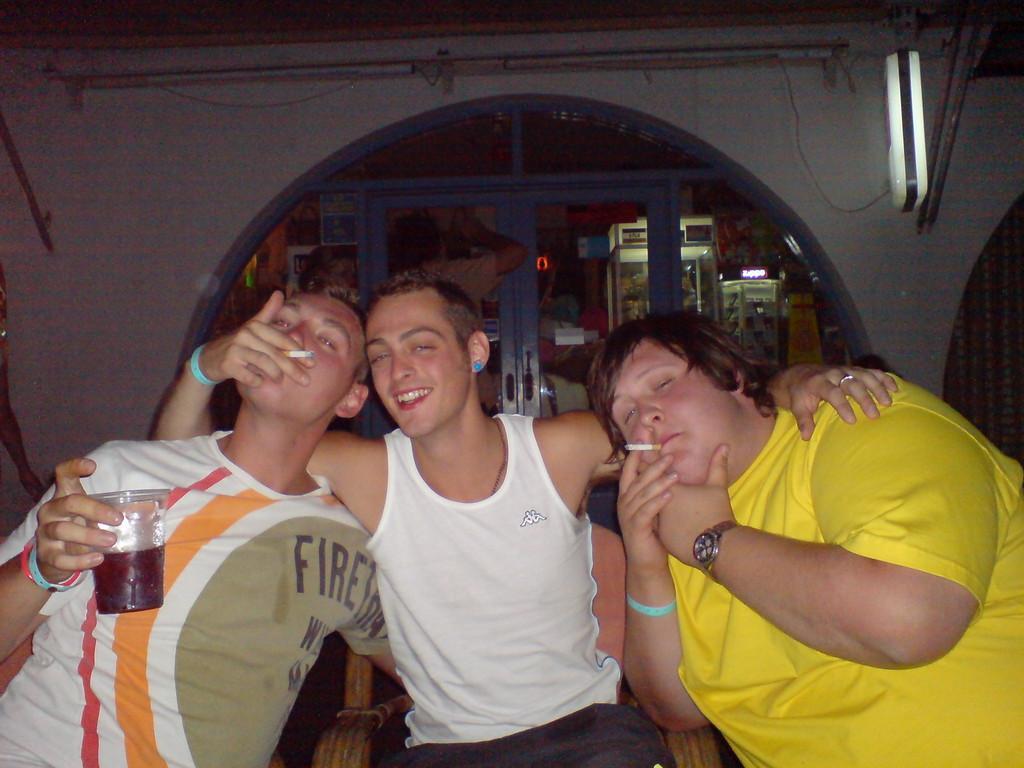Describe this image in one or two sentences. There are three persons sitting. Person on the left is holding a glass. They are wearing wristbands. Two are having cigarettes. In the back there is an arch. On the wall there are lights. In the background there are some other items. 